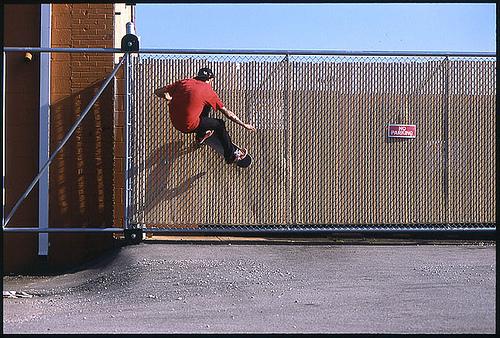Is he wearing a green shirt?
Concise answer only. No. What is prohibited by the sign?
Keep it brief. Parking. Is the fence retractable?
Keep it brief. Yes. 